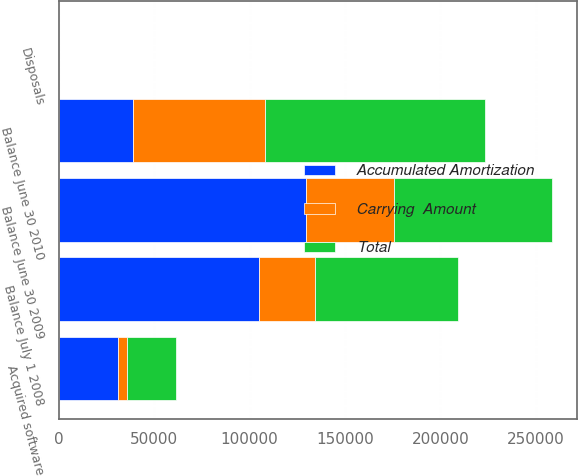Convert chart. <chart><loc_0><loc_0><loc_500><loc_500><stacked_bar_chart><ecel><fcel>Balance July 1 2008<fcel>Disposals<fcel>Balance June 30 2009<fcel>Acquired software<fcel>Balance June 30 2010<nl><fcel>Accumulated Amortization<fcel>104632<fcel>45<fcel>129271<fcel>30801<fcel>38696.5<nl><fcel>Carrying  Amount<fcel>29689<fcel>17<fcel>46592<fcel>4870<fcel>69228<nl><fcel>Total<fcel>74943<fcel>28<fcel>82679<fcel>25931<fcel>115647<nl></chart> 